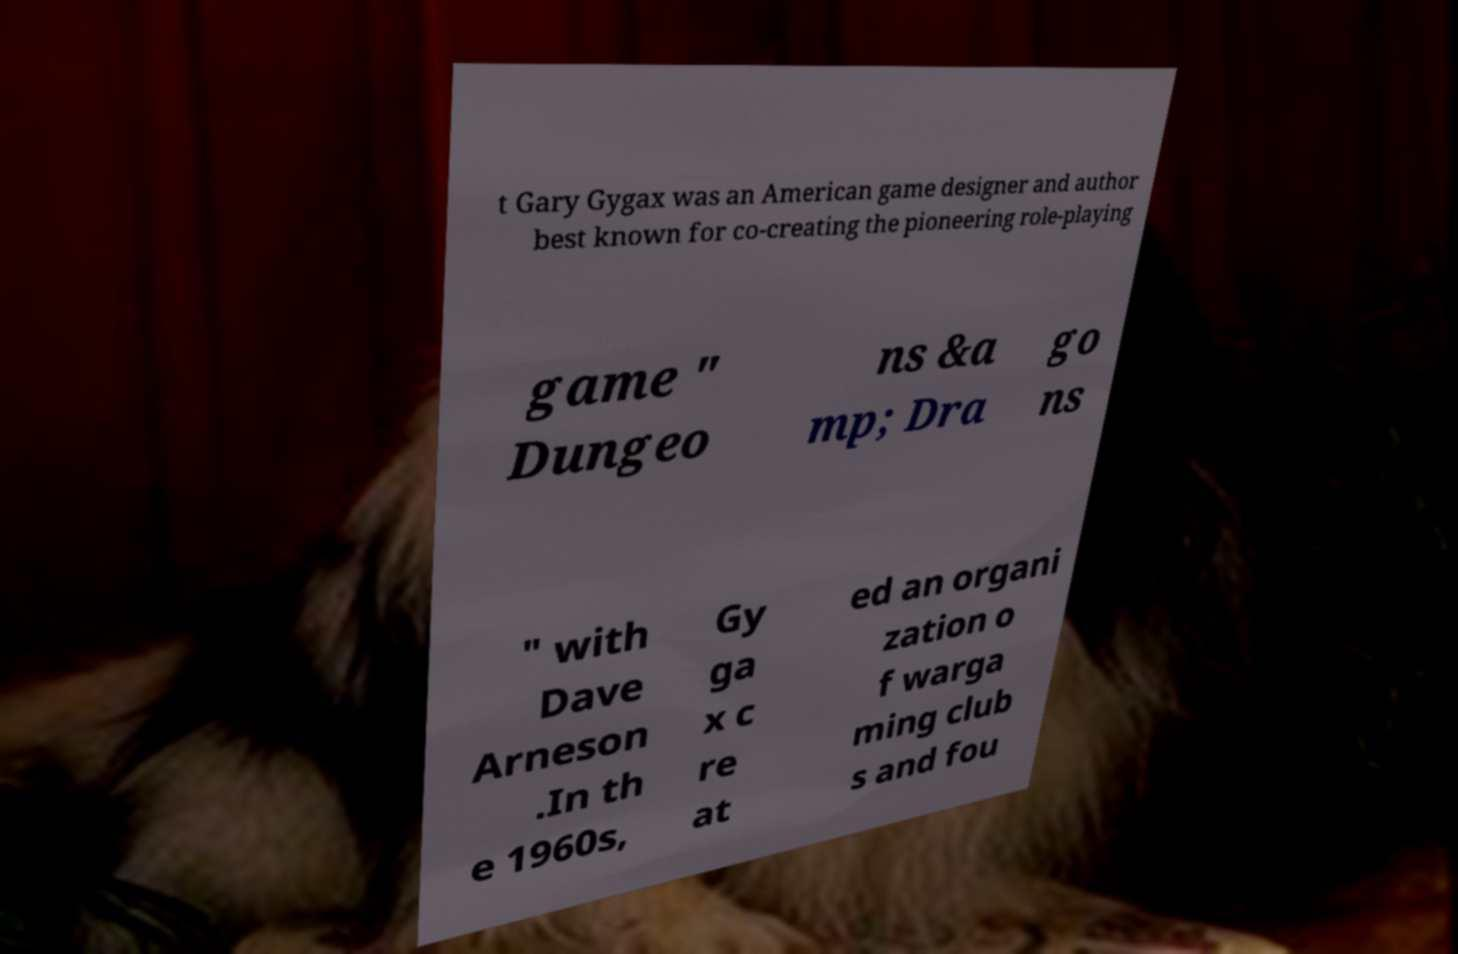Can you accurately transcribe the text from the provided image for me? t Gary Gygax was an American game designer and author best known for co-creating the pioneering role-playing game " Dungeo ns &a mp; Dra go ns " with Dave Arneson .In th e 1960s, Gy ga x c re at ed an organi zation o f warga ming club s and fou 